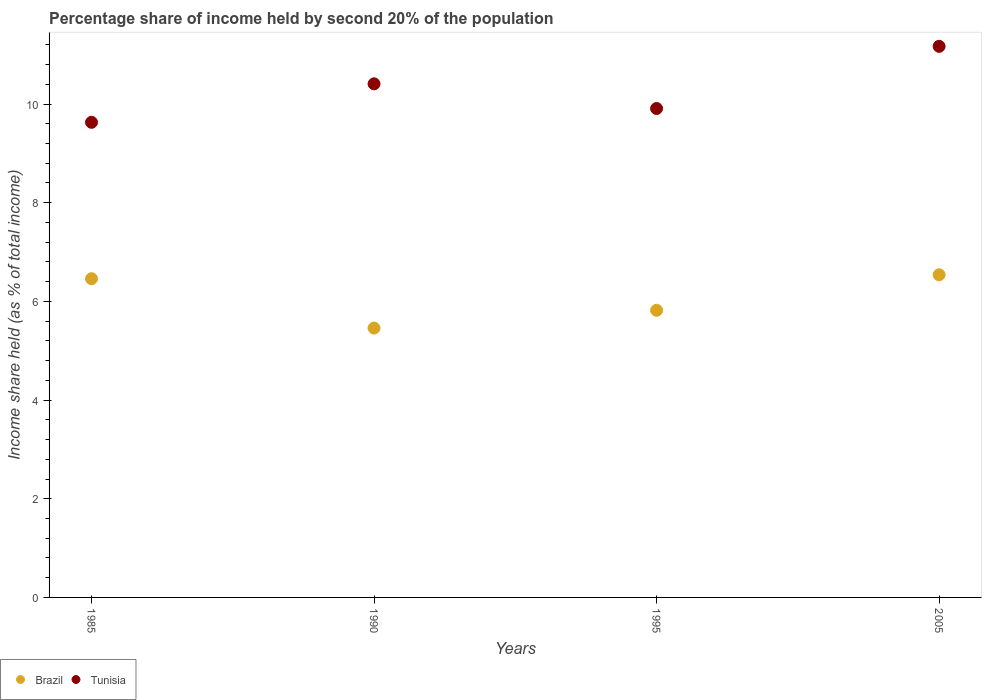How many different coloured dotlines are there?
Provide a short and direct response. 2. Is the number of dotlines equal to the number of legend labels?
Give a very brief answer. Yes. What is the share of income held by second 20% of the population in Brazil in 1985?
Ensure brevity in your answer.  6.46. Across all years, what is the maximum share of income held by second 20% of the population in Brazil?
Your answer should be compact. 6.54. Across all years, what is the minimum share of income held by second 20% of the population in Tunisia?
Provide a short and direct response. 9.63. In which year was the share of income held by second 20% of the population in Brazil minimum?
Ensure brevity in your answer.  1990. What is the total share of income held by second 20% of the population in Brazil in the graph?
Keep it short and to the point. 24.28. What is the difference between the share of income held by second 20% of the population in Tunisia in 1990 and that in 2005?
Offer a very short reply. -0.76. What is the difference between the share of income held by second 20% of the population in Brazil in 1995 and the share of income held by second 20% of the population in Tunisia in 2005?
Provide a short and direct response. -5.35. What is the average share of income held by second 20% of the population in Brazil per year?
Your answer should be very brief. 6.07. In the year 2005, what is the difference between the share of income held by second 20% of the population in Tunisia and share of income held by second 20% of the population in Brazil?
Provide a succinct answer. 4.63. What is the ratio of the share of income held by second 20% of the population in Brazil in 1985 to that in 1995?
Offer a terse response. 1.11. Is the share of income held by second 20% of the population in Tunisia in 1985 less than that in 1995?
Offer a terse response. Yes. Is the difference between the share of income held by second 20% of the population in Tunisia in 1995 and 2005 greater than the difference between the share of income held by second 20% of the population in Brazil in 1995 and 2005?
Make the answer very short. No. What is the difference between the highest and the second highest share of income held by second 20% of the population in Brazil?
Provide a succinct answer. 0.08. What is the difference between the highest and the lowest share of income held by second 20% of the population in Tunisia?
Ensure brevity in your answer.  1.54. Does the share of income held by second 20% of the population in Brazil monotonically increase over the years?
Give a very brief answer. No. Is the share of income held by second 20% of the population in Brazil strictly greater than the share of income held by second 20% of the population in Tunisia over the years?
Provide a succinct answer. No. Is the share of income held by second 20% of the population in Tunisia strictly less than the share of income held by second 20% of the population in Brazil over the years?
Your answer should be compact. No. What is the difference between two consecutive major ticks on the Y-axis?
Offer a very short reply. 2. Does the graph contain grids?
Offer a terse response. No. Where does the legend appear in the graph?
Your answer should be very brief. Bottom left. How many legend labels are there?
Your answer should be very brief. 2. What is the title of the graph?
Provide a short and direct response. Percentage share of income held by second 20% of the population. What is the label or title of the X-axis?
Offer a terse response. Years. What is the label or title of the Y-axis?
Ensure brevity in your answer.  Income share held (as % of total income). What is the Income share held (as % of total income) of Brazil in 1985?
Provide a succinct answer. 6.46. What is the Income share held (as % of total income) of Tunisia in 1985?
Your answer should be very brief. 9.63. What is the Income share held (as % of total income) in Brazil in 1990?
Offer a very short reply. 5.46. What is the Income share held (as % of total income) in Tunisia in 1990?
Your answer should be compact. 10.41. What is the Income share held (as % of total income) of Brazil in 1995?
Provide a succinct answer. 5.82. What is the Income share held (as % of total income) in Tunisia in 1995?
Offer a very short reply. 9.91. What is the Income share held (as % of total income) of Brazil in 2005?
Ensure brevity in your answer.  6.54. What is the Income share held (as % of total income) of Tunisia in 2005?
Give a very brief answer. 11.17. Across all years, what is the maximum Income share held (as % of total income) of Brazil?
Your answer should be compact. 6.54. Across all years, what is the maximum Income share held (as % of total income) in Tunisia?
Your answer should be very brief. 11.17. Across all years, what is the minimum Income share held (as % of total income) in Brazil?
Your answer should be very brief. 5.46. Across all years, what is the minimum Income share held (as % of total income) of Tunisia?
Your response must be concise. 9.63. What is the total Income share held (as % of total income) of Brazil in the graph?
Keep it short and to the point. 24.28. What is the total Income share held (as % of total income) in Tunisia in the graph?
Offer a terse response. 41.12. What is the difference between the Income share held (as % of total income) of Brazil in 1985 and that in 1990?
Your answer should be very brief. 1. What is the difference between the Income share held (as % of total income) of Tunisia in 1985 and that in 1990?
Provide a succinct answer. -0.78. What is the difference between the Income share held (as % of total income) of Brazil in 1985 and that in 1995?
Your answer should be compact. 0.64. What is the difference between the Income share held (as % of total income) of Tunisia in 1985 and that in 1995?
Provide a succinct answer. -0.28. What is the difference between the Income share held (as % of total income) of Brazil in 1985 and that in 2005?
Offer a very short reply. -0.08. What is the difference between the Income share held (as % of total income) of Tunisia in 1985 and that in 2005?
Your response must be concise. -1.54. What is the difference between the Income share held (as % of total income) in Brazil in 1990 and that in 1995?
Your response must be concise. -0.36. What is the difference between the Income share held (as % of total income) of Tunisia in 1990 and that in 1995?
Your response must be concise. 0.5. What is the difference between the Income share held (as % of total income) in Brazil in 1990 and that in 2005?
Provide a succinct answer. -1.08. What is the difference between the Income share held (as % of total income) in Tunisia in 1990 and that in 2005?
Give a very brief answer. -0.76. What is the difference between the Income share held (as % of total income) of Brazil in 1995 and that in 2005?
Your answer should be compact. -0.72. What is the difference between the Income share held (as % of total income) of Tunisia in 1995 and that in 2005?
Your response must be concise. -1.26. What is the difference between the Income share held (as % of total income) in Brazil in 1985 and the Income share held (as % of total income) in Tunisia in 1990?
Keep it short and to the point. -3.95. What is the difference between the Income share held (as % of total income) of Brazil in 1985 and the Income share held (as % of total income) of Tunisia in 1995?
Provide a short and direct response. -3.45. What is the difference between the Income share held (as % of total income) of Brazil in 1985 and the Income share held (as % of total income) of Tunisia in 2005?
Ensure brevity in your answer.  -4.71. What is the difference between the Income share held (as % of total income) of Brazil in 1990 and the Income share held (as % of total income) of Tunisia in 1995?
Your response must be concise. -4.45. What is the difference between the Income share held (as % of total income) in Brazil in 1990 and the Income share held (as % of total income) in Tunisia in 2005?
Keep it short and to the point. -5.71. What is the difference between the Income share held (as % of total income) of Brazil in 1995 and the Income share held (as % of total income) of Tunisia in 2005?
Keep it short and to the point. -5.35. What is the average Income share held (as % of total income) in Brazil per year?
Give a very brief answer. 6.07. What is the average Income share held (as % of total income) in Tunisia per year?
Give a very brief answer. 10.28. In the year 1985, what is the difference between the Income share held (as % of total income) in Brazil and Income share held (as % of total income) in Tunisia?
Your response must be concise. -3.17. In the year 1990, what is the difference between the Income share held (as % of total income) in Brazil and Income share held (as % of total income) in Tunisia?
Keep it short and to the point. -4.95. In the year 1995, what is the difference between the Income share held (as % of total income) in Brazil and Income share held (as % of total income) in Tunisia?
Ensure brevity in your answer.  -4.09. In the year 2005, what is the difference between the Income share held (as % of total income) in Brazil and Income share held (as % of total income) in Tunisia?
Your response must be concise. -4.63. What is the ratio of the Income share held (as % of total income) in Brazil in 1985 to that in 1990?
Offer a very short reply. 1.18. What is the ratio of the Income share held (as % of total income) of Tunisia in 1985 to that in 1990?
Offer a terse response. 0.93. What is the ratio of the Income share held (as % of total income) in Brazil in 1985 to that in 1995?
Ensure brevity in your answer.  1.11. What is the ratio of the Income share held (as % of total income) of Tunisia in 1985 to that in 1995?
Offer a terse response. 0.97. What is the ratio of the Income share held (as % of total income) in Brazil in 1985 to that in 2005?
Make the answer very short. 0.99. What is the ratio of the Income share held (as % of total income) in Tunisia in 1985 to that in 2005?
Give a very brief answer. 0.86. What is the ratio of the Income share held (as % of total income) in Brazil in 1990 to that in 1995?
Offer a terse response. 0.94. What is the ratio of the Income share held (as % of total income) in Tunisia in 1990 to that in 1995?
Keep it short and to the point. 1.05. What is the ratio of the Income share held (as % of total income) in Brazil in 1990 to that in 2005?
Offer a terse response. 0.83. What is the ratio of the Income share held (as % of total income) of Tunisia in 1990 to that in 2005?
Your answer should be very brief. 0.93. What is the ratio of the Income share held (as % of total income) of Brazil in 1995 to that in 2005?
Provide a succinct answer. 0.89. What is the ratio of the Income share held (as % of total income) of Tunisia in 1995 to that in 2005?
Give a very brief answer. 0.89. What is the difference between the highest and the second highest Income share held (as % of total income) of Tunisia?
Your answer should be compact. 0.76. What is the difference between the highest and the lowest Income share held (as % of total income) in Tunisia?
Offer a terse response. 1.54. 